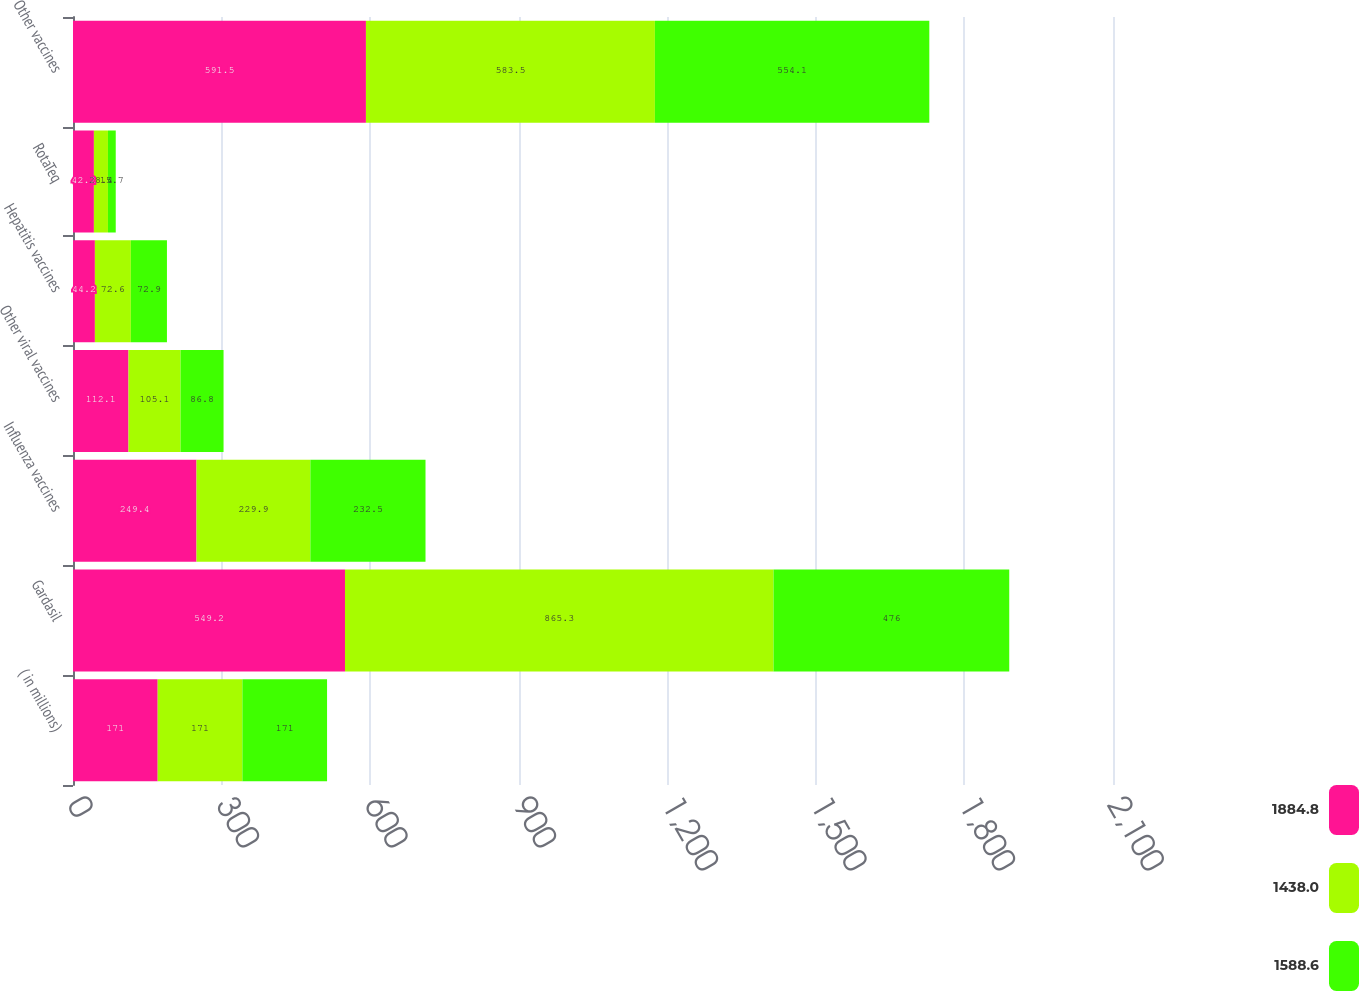Convert chart. <chart><loc_0><loc_0><loc_500><loc_500><stacked_bar_chart><ecel><fcel>( in millions)<fcel>Gardasil<fcel>Influenza vaccines<fcel>Other viral vaccines<fcel>Hepatitis vaccines<fcel>RotaTeq<fcel>Other vaccines<nl><fcel>1884.8<fcel>171<fcel>549.2<fcel>249.4<fcel>112.1<fcel>44.2<fcel>42.2<fcel>591.5<nl><fcel>1438<fcel>171<fcel>865.3<fcel>229.9<fcel>105.1<fcel>72.6<fcel>28.4<fcel>583.5<nl><fcel>1588.6<fcel>171<fcel>476<fcel>232.5<fcel>86.8<fcel>72.9<fcel>15.7<fcel>554.1<nl></chart> 